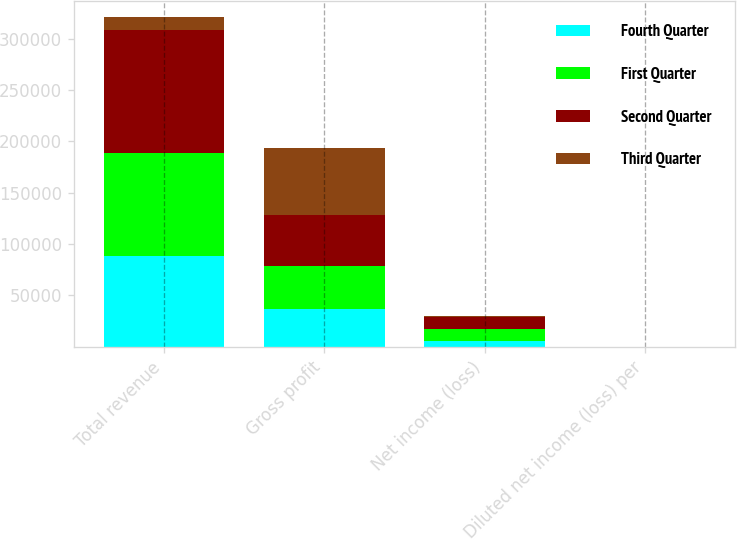Convert chart. <chart><loc_0><loc_0><loc_500><loc_500><stacked_bar_chart><ecel><fcel>Total revenue<fcel>Gross profit<fcel>Net income (loss)<fcel>Diluted net income (loss) per<nl><fcel>Fourth Quarter<fcel>87956<fcel>36290<fcel>5716<fcel>0.12<nl><fcel>First Quarter<fcel>100985<fcel>42429<fcel>11164<fcel>0.24<nl><fcel>Second Quarter<fcel>119685<fcel>49660<fcel>12017<fcel>0.25<nl><fcel>Third Quarter<fcel>12017<fcel>65153<fcel>1473<fcel>0.03<nl></chart> 